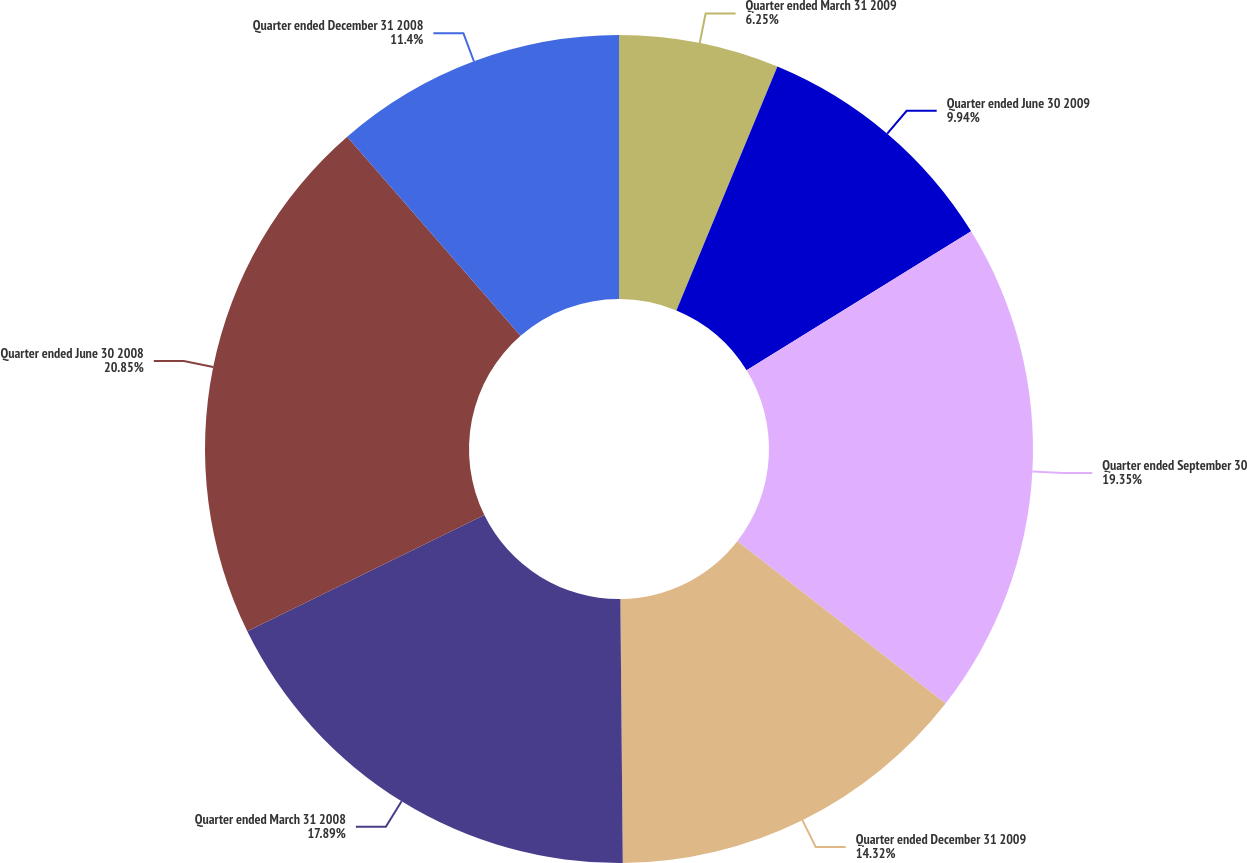<chart> <loc_0><loc_0><loc_500><loc_500><pie_chart><fcel>Quarter ended March 31 2009<fcel>Quarter ended June 30 2009<fcel>Quarter ended September 30<fcel>Quarter ended December 31 2009<fcel>Quarter ended March 31 2008<fcel>Quarter ended June 30 2008<fcel>Quarter ended December 31 2008<nl><fcel>6.25%<fcel>9.94%<fcel>19.35%<fcel>14.32%<fcel>17.89%<fcel>20.86%<fcel>11.4%<nl></chart> 